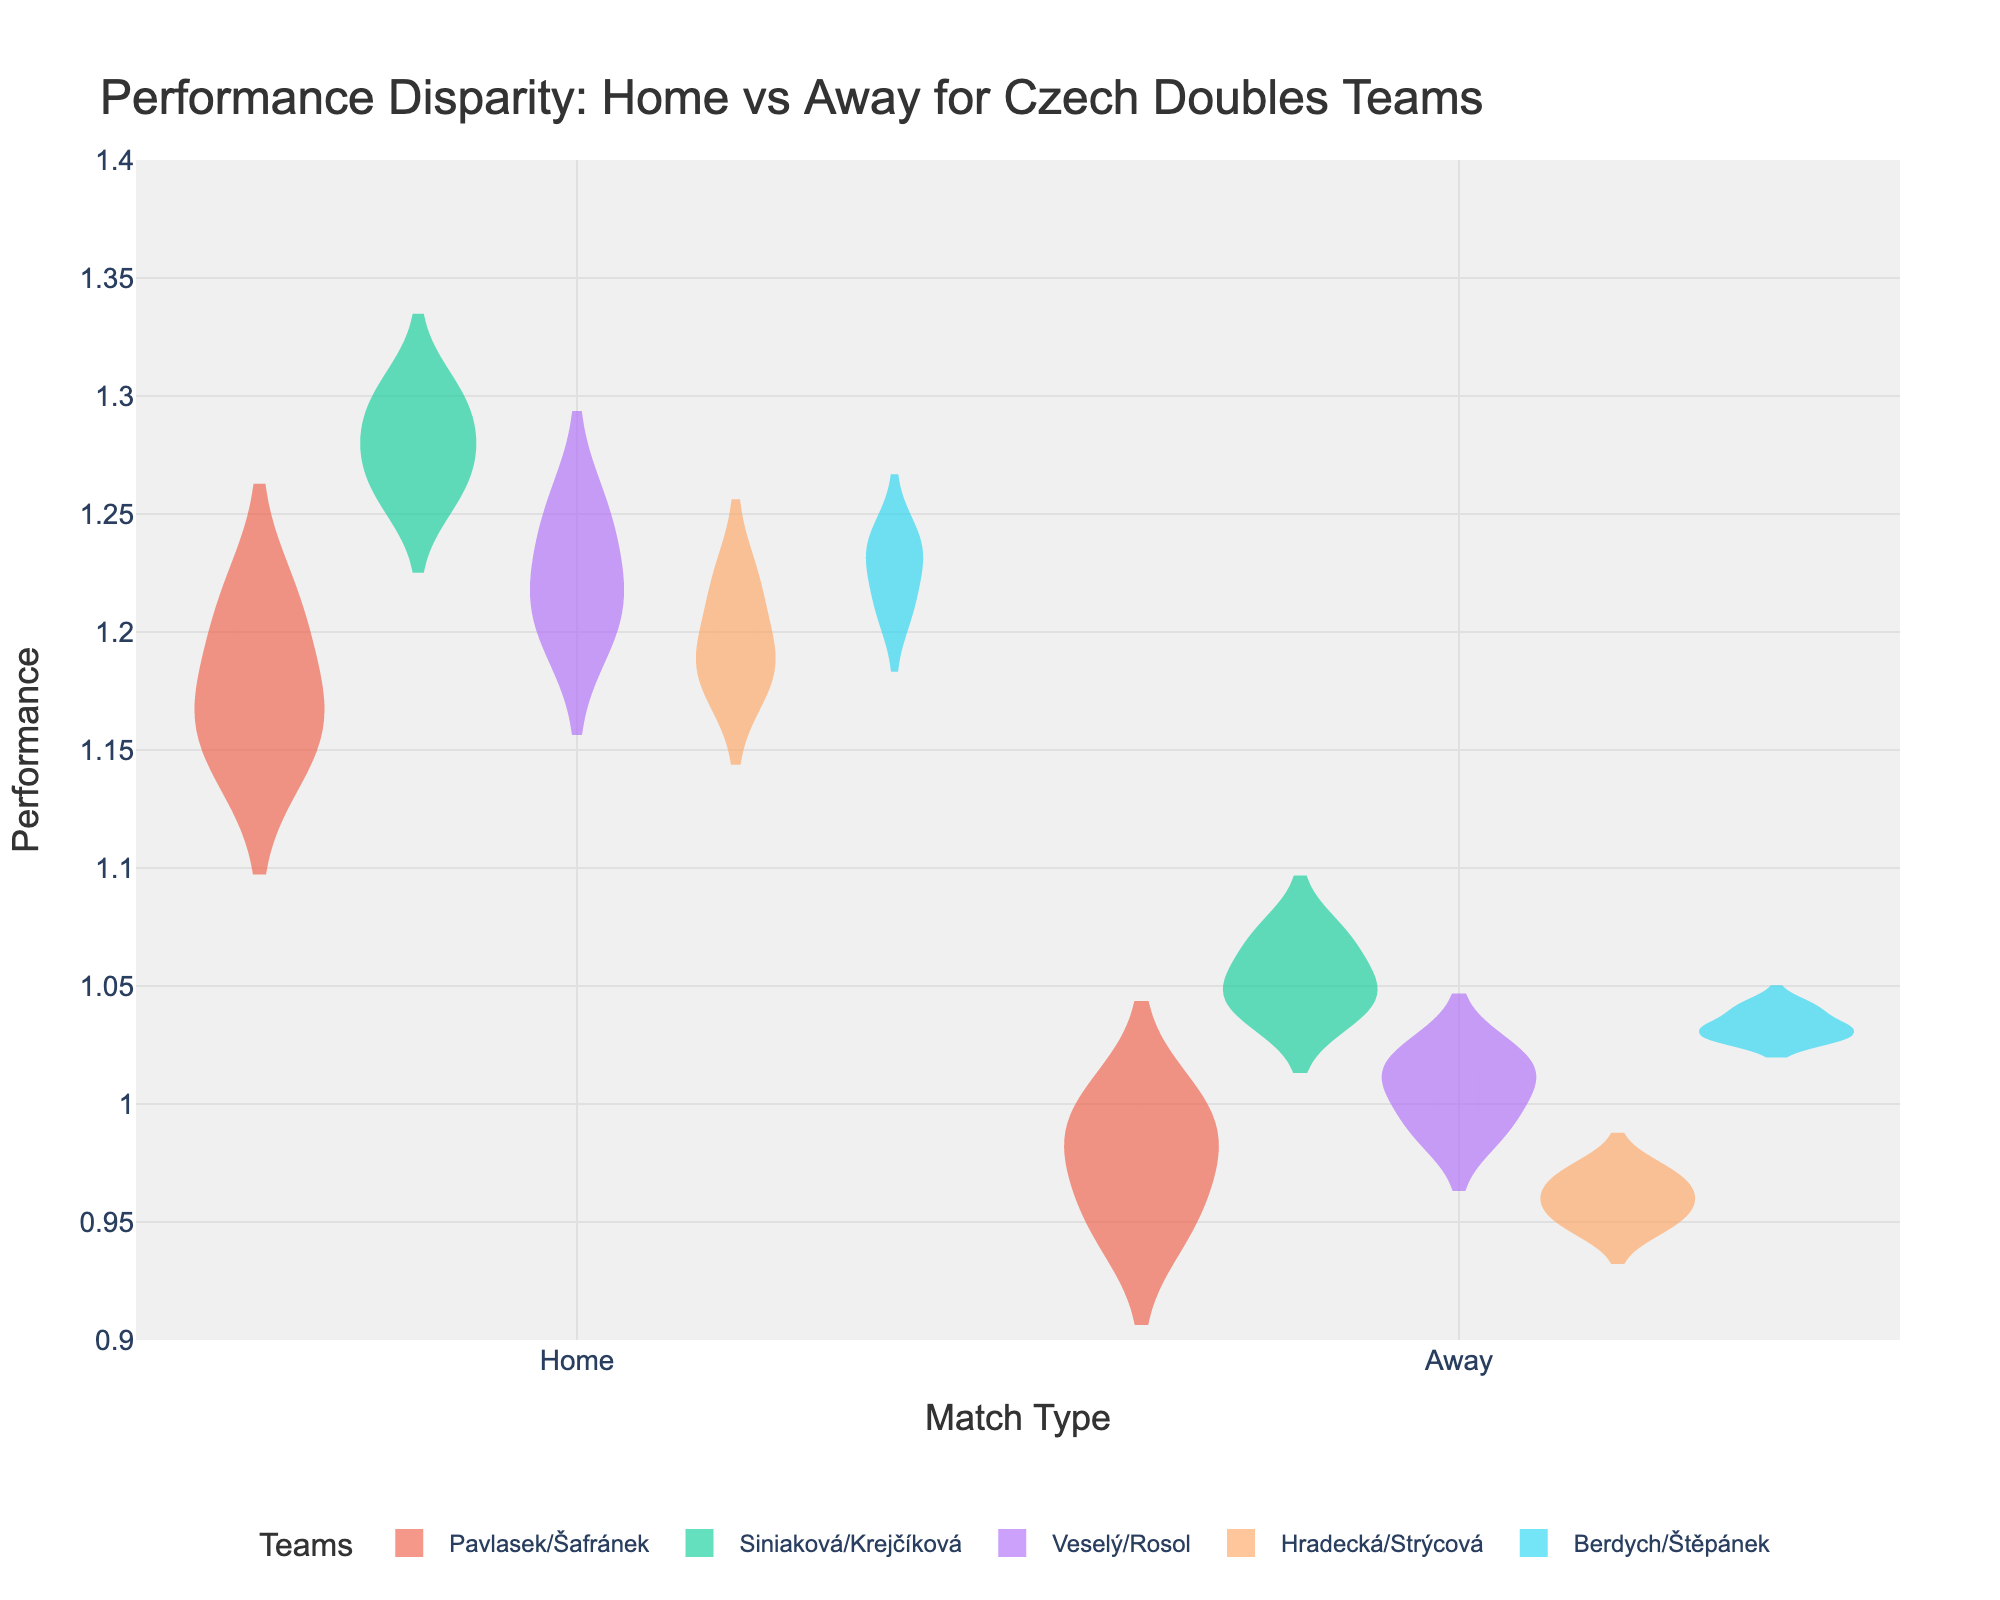What's the title of the figure? The title of the figure is at the top and usually summarizes the main topic depicted in the plot. In this case, it states "Performance Disparity: Home vs Away for Czech Doubles Teams".
Answer: Performance Disparity: Home vs Away for Czech Doubles Teams What does the y-axis represent? The y-axis title is provided and it indicates what is being measured on the vertical scale. According to the figure, it represents "Performance".
Answer: Performance How does the performance of Siniaková/Krejčíková in home matches compare to away matches? By looking at the distribution and the box plot overlay for Siniaková/Krejčíková in both "Home" and "Away" categories, it's clear to see the home matches have higher performance values than the away matches.
Answer: Higher in home matches Which team has the biggest disparity between home and away match performance? By comparing the spread and median values of each team's performance in home and away matches, you can identify that Siniaková/Krejčíková have the largest disparity, with a higher concentration of values at home compared to away.
Answer: Siniaková/Krejčíková What can you say about the distribution of Veselý/Rosol's performance in home matches? The violin plot and the box plot parts show the distribution. Veselý/Rosol's home matches have a narrower and higher distribution of performance values clustered around the mean, suggesting consistent strong performance.
Answer: Consistent strong performance Which team has the lowest median performance in away matches? By observing the median line in the away section of each team's violin plot, it's evident that Hradecká/Strýcová have the lowest median performance in away matches.
Answer: Hradecká/Strýcová Is the variance in performance higher for home or away matches for Berdych/Štěpánek? By examining the width and spread of Berdych/Štěpánek’s violin plots, it's noticeable that the variance for away matches is wider compared to home matches, indicating higher performance variability when playing away.
Answer: Higher for away matches Which team consistently performs better in both home and away matches? Observing the center and the spread of the distributions for each team, Siniaková/Krejčíková consistently show high performance in both home and away matches compared to others.
Answer: Siniaková/Krejčíková 